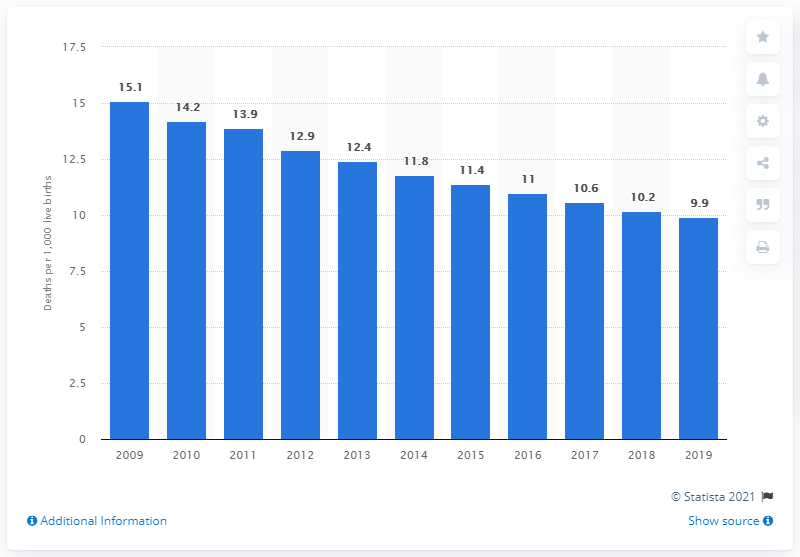Mention a couple of crucial points in this snapshot. The infant mortality rate in Libya in 2019 was 9.9 per 1,000 live births. 